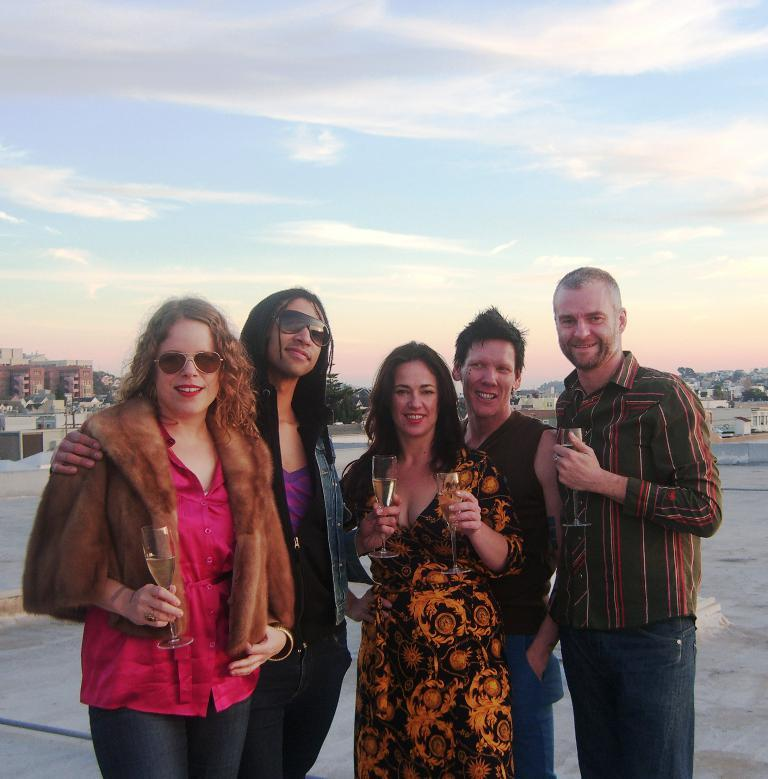Who or what is present in the image? There are people in the image. What are the people holding in their hands? The people are holding glasses in their hands. What is the facial expression of the people in the image? The people are smiling. What can be seen in the distance behind the people? There are buildings visible in the background of the image. What type of silk fabric is draped over the zoo enclosure in the image? There is no silk fabric or zoo enclosure present in the image. 